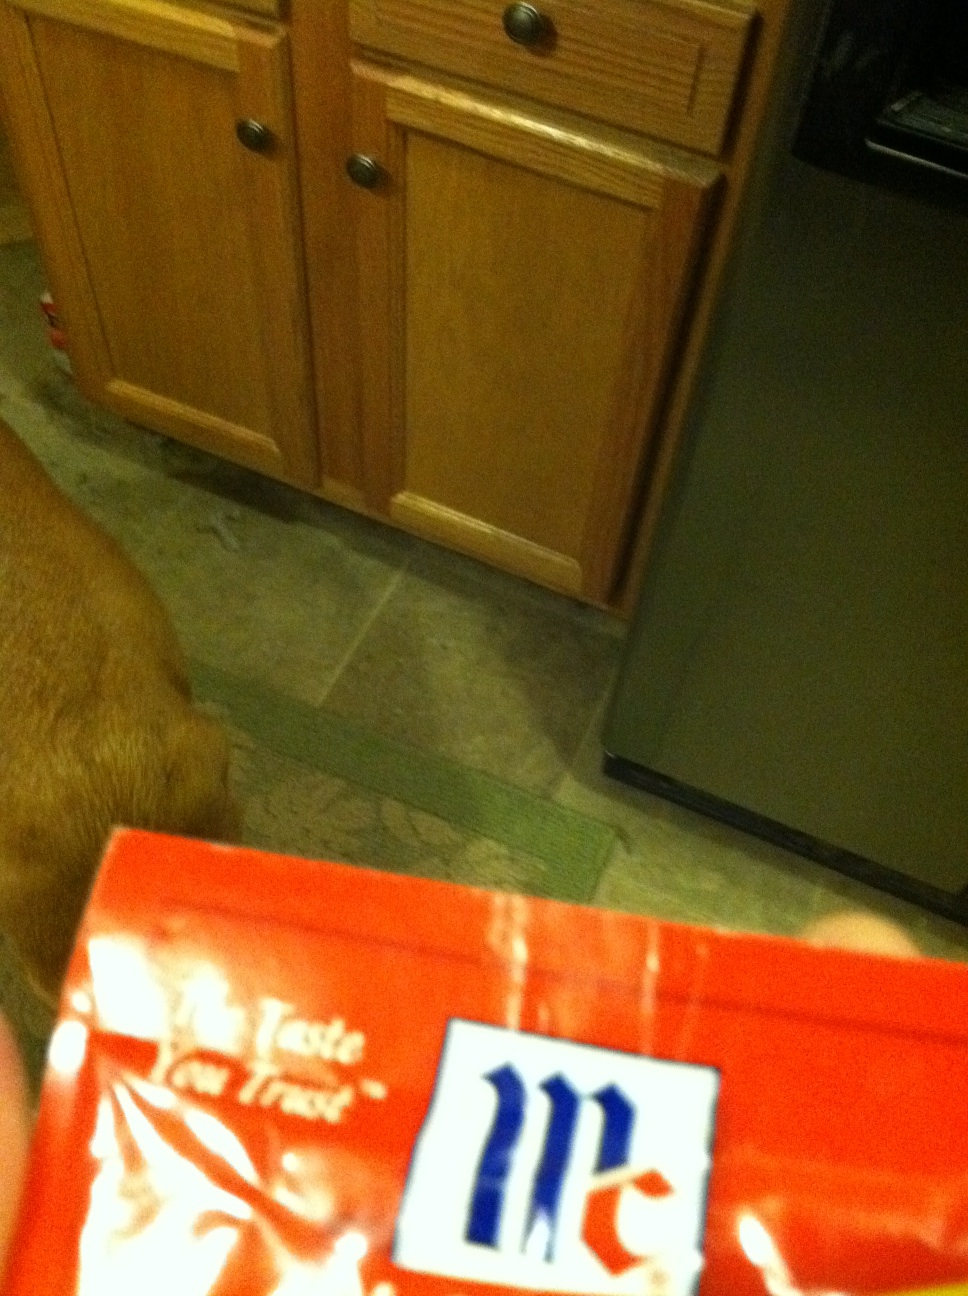Can you tell me what's in this food envelope please? The image shows a tightly held, partially visible packet which appears to contain a sauce or a cooking additive, often used in seasoning food. However, without more details or visibility of the contents, it's challenging to specify exactly what the packet contains. 